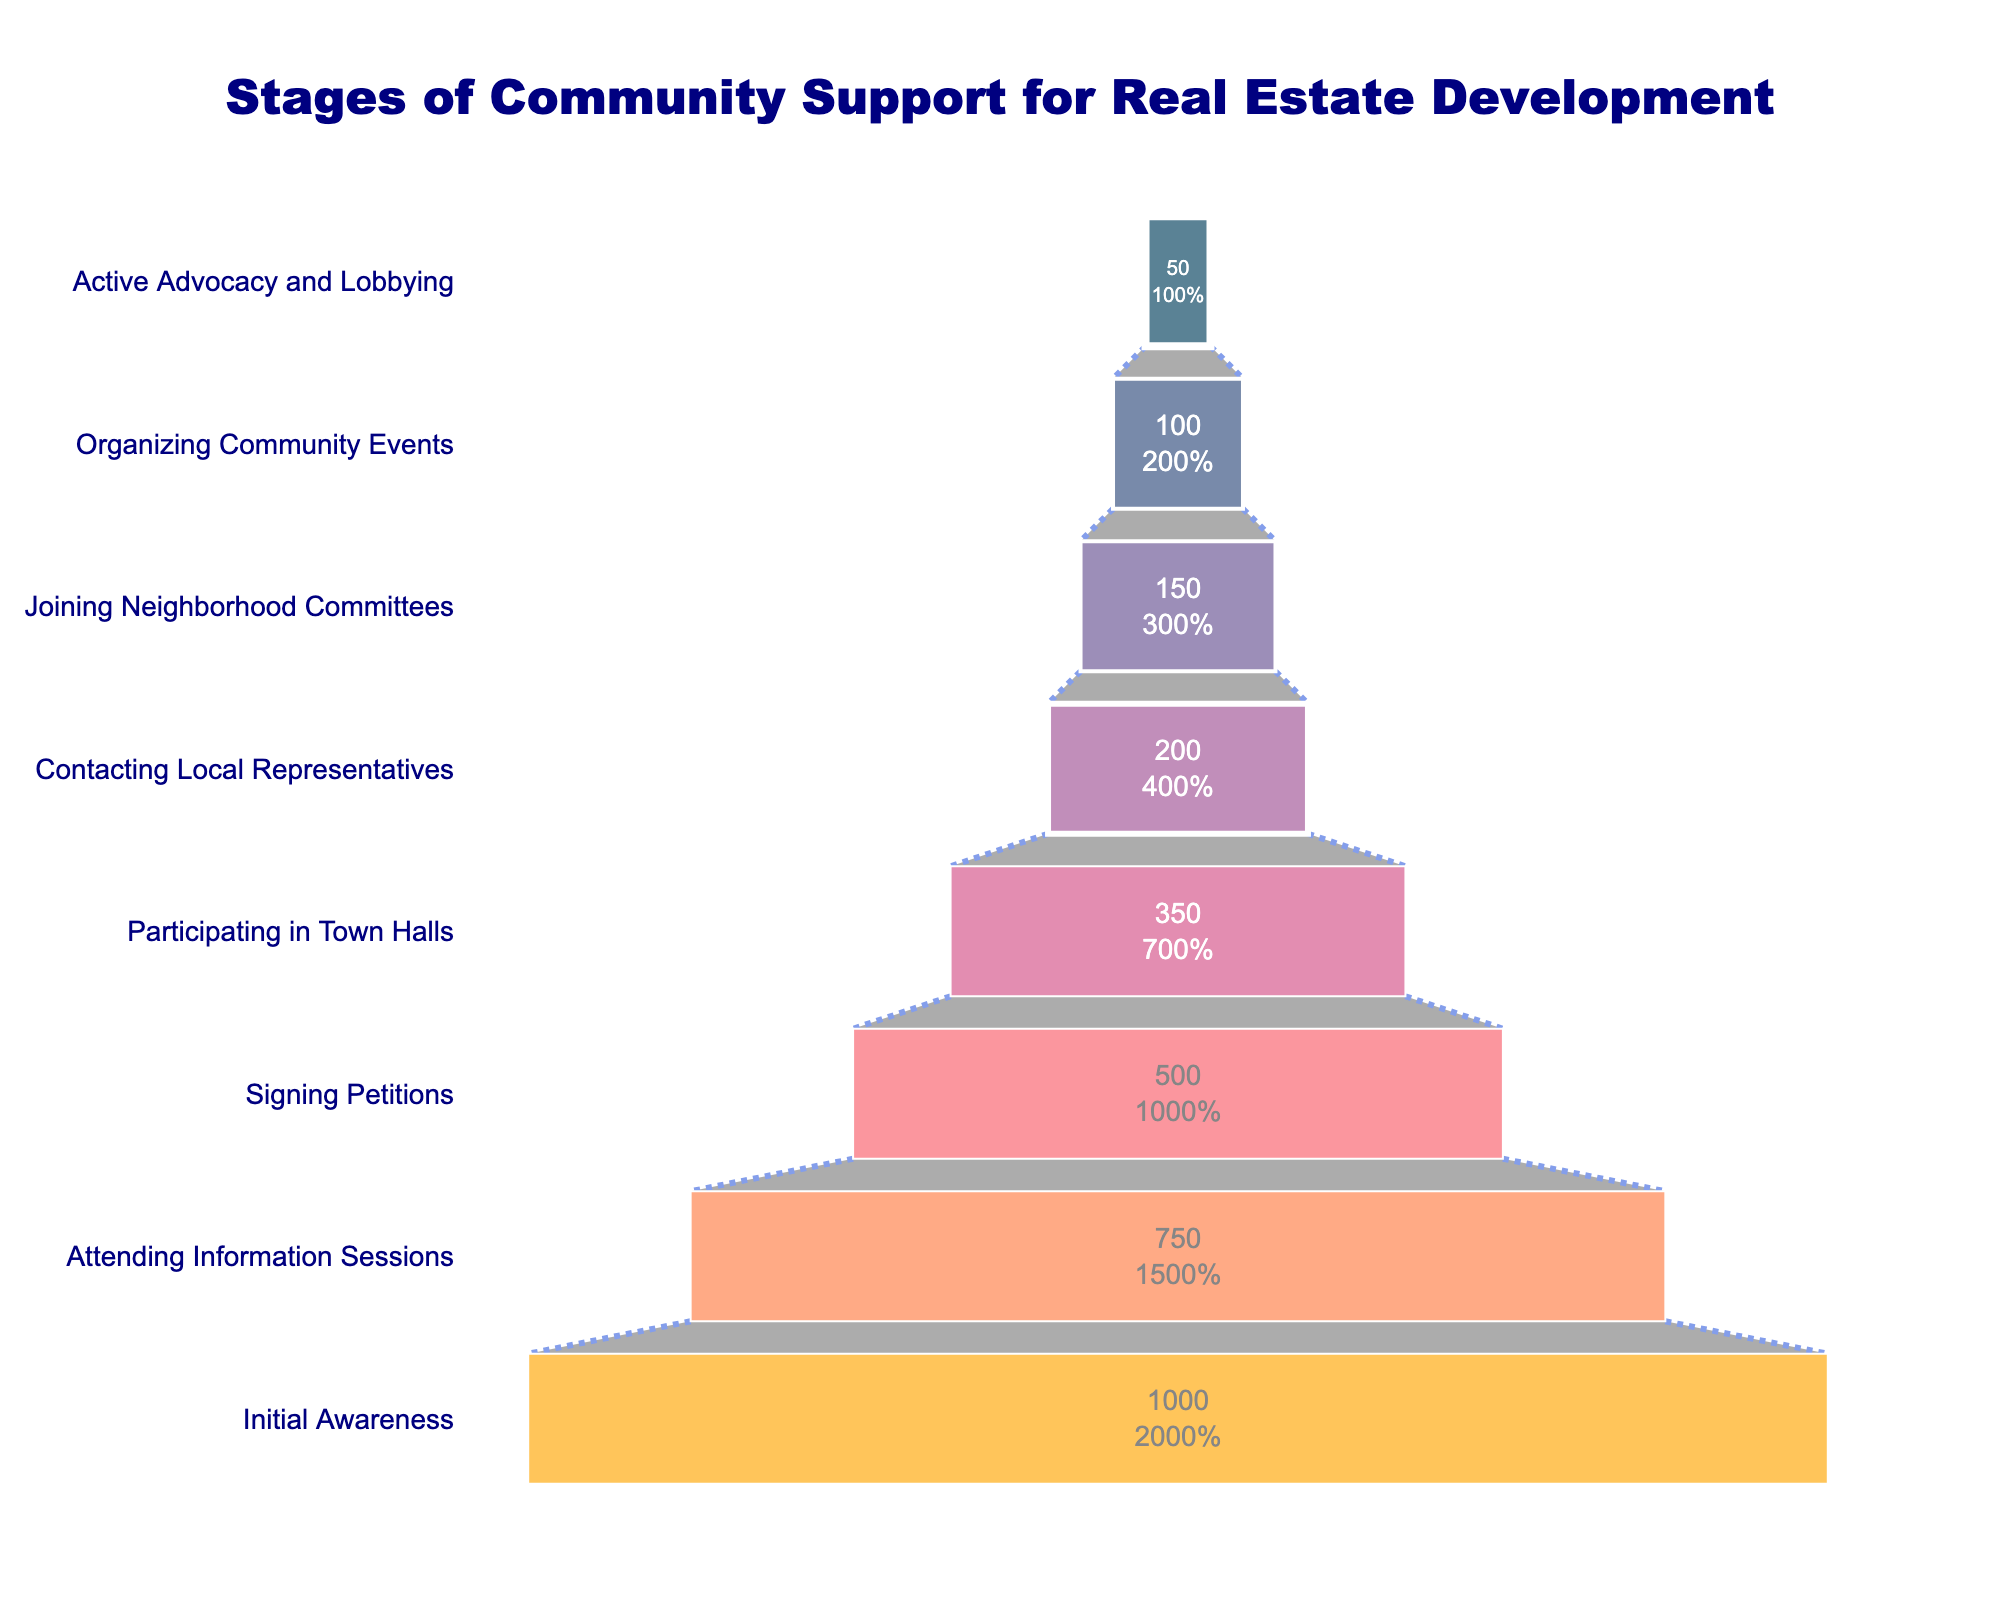What's the title of the funnel chart? The title is usually positioned at the top of the chart. Here, it clearly states the focus of the funnel chart.
Answer: Stages of Community Support for Real Estate Development How many stages are shown in the funnel chart? The number of stages can be determined by counting the distinct segments or layers in the funnel.
Answer: 8 What is the first stage of community support identified in the chart? The first stage is usually at the widest part of the funnel, as it represents the initial group before any filtering process.
Answer: Initial Awareness How many community members are actively advocating and lobbying in the final stage? The number of community members in the final stage can be observed directly from the data label inside or beside the corresponding segment of the funnel.
Answer: 50 How does the number of members attending information sessions compare to those signing petitions? Compare the numbers of community members at the two stages mentioned.
Answer: 750 attend information sessions; 500 sign petitions What percentage of the initial awareness group is involved in contacting local representatives? Here, we need to divide the number of members contacting local representatives by the number in the initial awareness group, then multiply by 100.
Answer: (200 / 1000) * 100 = 20% Which stage has the largest decrease in community members from the previous stage? Calculate the difference in community members between consecutive stages and identify the largest decrease.
Answer: Signing Petitions to Participating in Town Halls; 500 to 350 (decrease of 150) How many community members are involved in organizing community events? Identify the number of members in the specific stage within the funnel.
Answer: 100 What is the difference in the number of community members between signing petitions and participating in town halls? Subtract the number of members participating in town halls from the number signing petitions.
Answer: 500 - 350 = 150 Considering the funnel chart, which color is used to represent the largest community group? The color representing the widest segment at the top of the funnel corresponds to the largest community group. The chart's color scheme can help identify this.
Answer: Dark blue (Initial Awareness with 1000 members) 